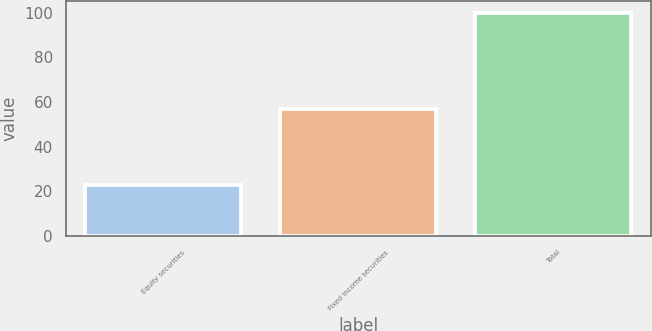<chart> <loc_0><loc_0><loc_500><loc_500><bar_chart><fcel>Equity securities<fcel>Fixed income securities<fcel>Total<nl><fcel>23<fcel>57<fcel>100<nl></chart> 